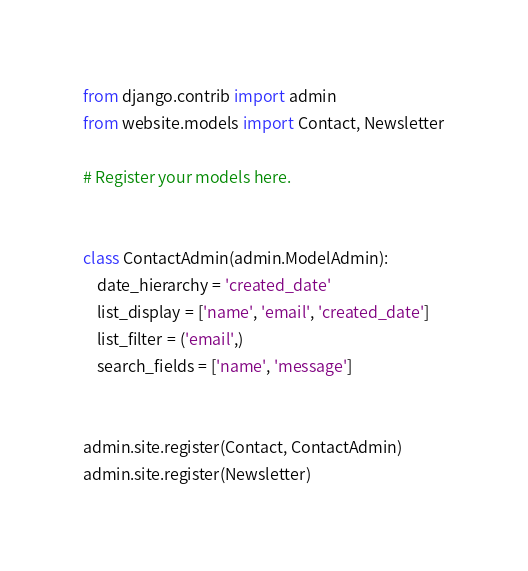<code> <loc_0><loc_0><loc_500><loc_500><_Python_>from django.contrib import admin
from website.models import Contact, Newsletter

# Register your models here.


class ContactAdmin(admin.ModelAdmin):
    date_hierarchy = 'created_date'
    list_display = ['name', 'email', 'created_date']
    list_filter = ('email',)
    search_fields = ['name', 'message']


admin.site.register(Contact, ContactAdmin)
admin.site.register(Newsletter)
</code> 